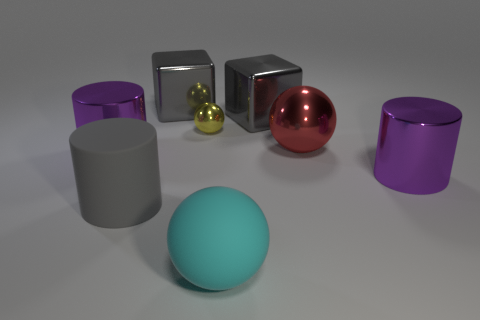Are there any other things that have the same size as the yellow ball?
Keep it short and to the point. No. Do the big gray cylinder and the red object have the same material?
Ensure brevity in your answer.  No. How many objects are either gray cylinders or large red shiny objects?
Your answer should be very brief. 2. What is the shape of the large rubber object in front of the gray matte cylinder?
Make the answer very short. Sphere. What color is the thing that is the same material as the big cyan sphere?
Ensure brevity in your answer.  Gray. There is a yellow object that is the same shape as the red thing; what material is it?
Ensure brevity in your answer.  Metal. The tiny metal object is what shape?
Your answer should be very brief. Sphere. What is the material of the ball that is behind the large rubber ball and right of the tiny yellow metal thing?
Your response must be concise. Metal. What is the shape of the big red thing that is the same material as the yellow ball?
Your answer should be compact. Sphere. What is the size of the other ball that is the same material as the red sphere?
Your answer should be compact. Small. 